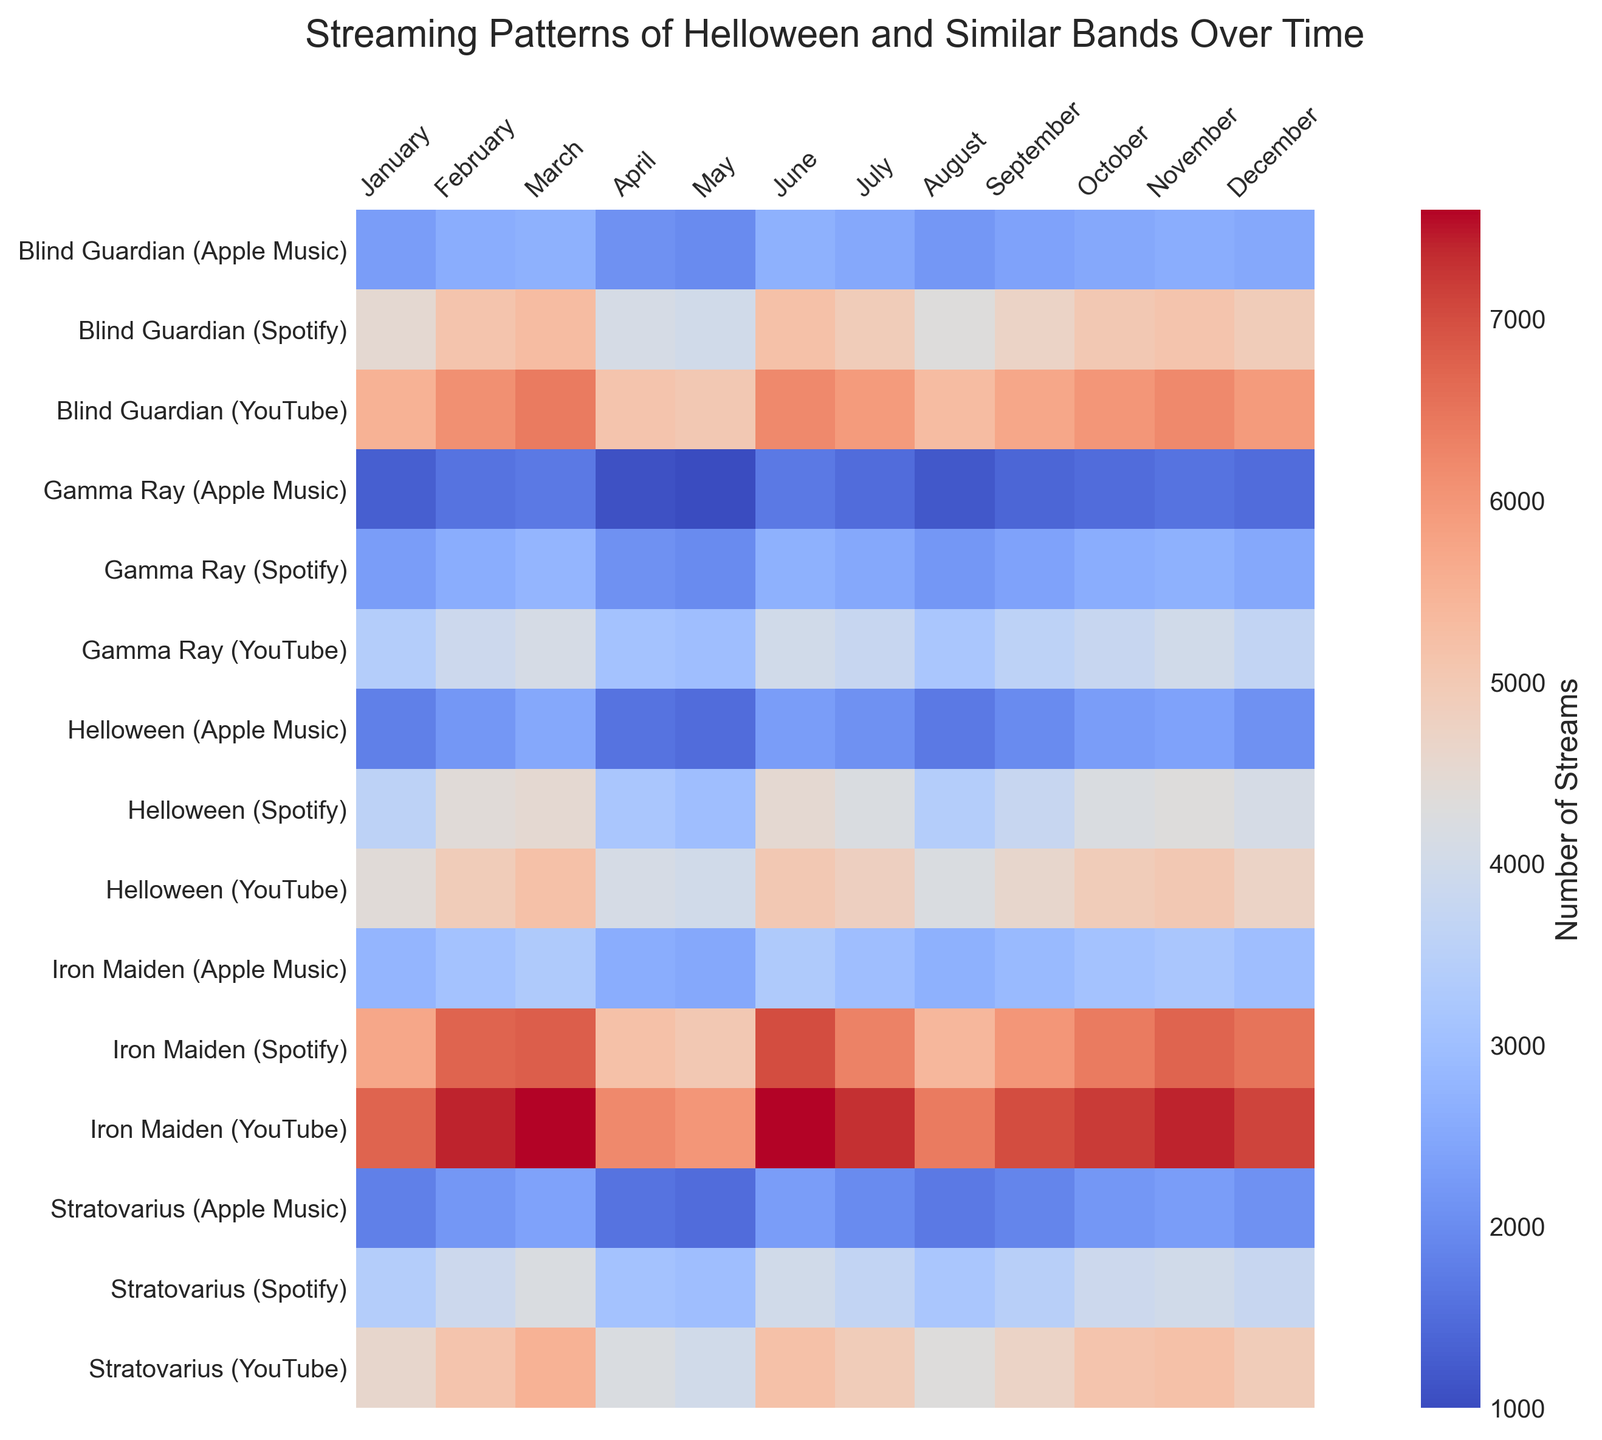Which platform has the highest streaming number for Helloween in December? The heatmap shows different colors representing the number of streams. For Helloween in December, find the darkest (most intense) color. The row corresponding to YouTube for Helloween has the darkest color, indicating the highest number of streams.
Answer: YouTube How do the streaming numbers for Iron Maiden on Spotify compare between April and July? Identify the color intensity for Iron Maiden on Spotify for April and July. The color for July is darker than April, indicating higher streaming numbers in July.
Answer: Higher in July Which month shows the lowest streaming numbers for Blind Guardian on Apple Music? Look for the lightest color in the row corresponding to Blind Guardian on Apple Music. The lightest color appears in January and February, indicating the lowest streaming numbers.
Answer: January and February What's the difference in streaming numbers between Helloween and Gamma Ray on Spotify in June? Identify the colors representing the streaming numbers for Helloween and Gamma Ray on Spotify in June. Helloween's color is much darker, showing 4200 streams, compared to Gamma Ray's 2500. Calculate the difference, 4200 - 2500 = 1700.
Answer: 1700 Which band has the most consistent streaming pattern across all platforms throughout the year? Consistent streaming patterns would show minimal variation in color intensity across months for bands. Scan each band's rows. Blind Guardian shows evenly distributed color intensities across all platforms without sudden changes, indicating consistency.
Answer: Blind Guardian In which month does Iron Maiden have the highest combined number of streams across all platforms? To find the combined streams, sum the intensity of the colors for Iron Maiden across all platforms for each month. The month with the darkest combined shades is July, indicating the highest streaming numbers.
Answer: July Describe the trend in Helloween's streaming numbers on Spotify throughout the year. Observe the progression of color intensity from January to December for Helloween on Spotify. The intensity grows progressively darker, indicating an upward trend in streaming numbers throughout the year.
Answer: Increasing Which band has the highest streaming peak on YouTube in any given month? Look for the darkest shade in rows corresponding to YouTube across all bands. Iron Maiden in July shows the most intense color, indicating the highest peak.
Answer: Iron Maiden On which platform does Gamma Ray have their highest average streaming numbers? Compare the color intensities for Gamma Ray across each platform. The row for YouTube generally shows darker colors compared to Spotify and Apple Music, implying higher average numbers.
Answer: YouTube 